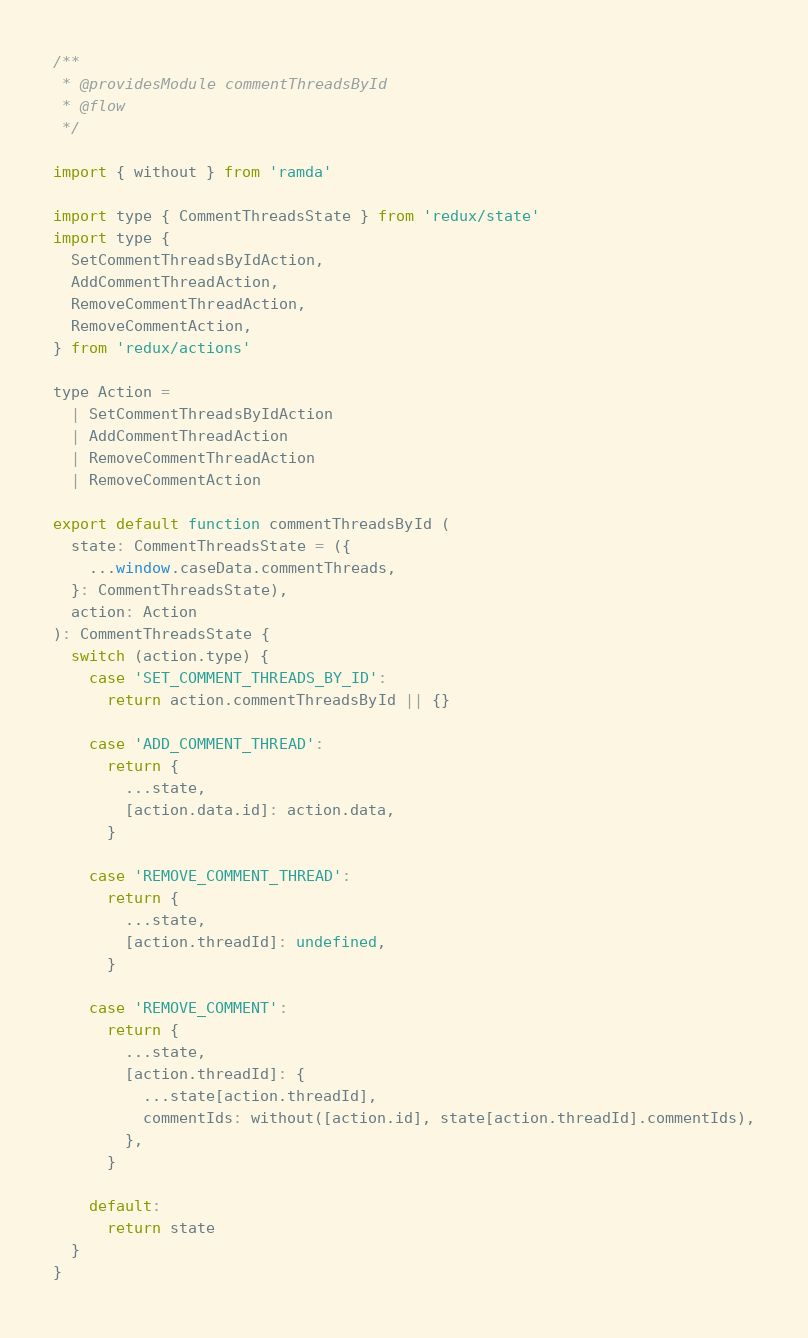Convert code to text. <code><loc_0><loc_0><loc_500><loc_500><_JavaScript_>/**
 * @providesModule commentThreadsById
 * @flow
 */

import { without } from 'ramda'

import type { CommentThreadsState } from 'redux/state'
import type {
  SetCommentThreadsByIdAction,
  AddCommentThreadAction,
  RemoveCommentThreadAction,
  RemoveCommentAction,
} from 'redux/actions'

type Action =
  | SetCommentThreadsByIdAction
  | AddCommentThreadAction
  | RemoveCommentThreadAction
  | RemoveCommentAction

export default function commentThreadsById (
  state: CommentThreadsState = ({
    ...window.caseData.commentThreads,
  }: CommentThreadsState),
  action: Action
): CommentThreadsState {
  switch (action.type) {
    case 'SET_COMMENT_THREADS_BY_ID':
      return action.commentThreadsById || {}

    case 'ADD_COMMENT_THREAD':
      return {
        ...state,
        [action.data.id]: action.data,
      }

    case 'REMOVE_COMMENT_THREAD':
      return {
        ...state,
        [action.threadId]: undefined,
      }

    case 'REMOVE_COMMENT':
      return {
        ...state,
        [action.threadId]: {
          ...state[action.threadId],
          commentIds: without([action.id], state[action.threadId].commentIds),
        },
      }

    default:
      return state
  }
}
</code> 